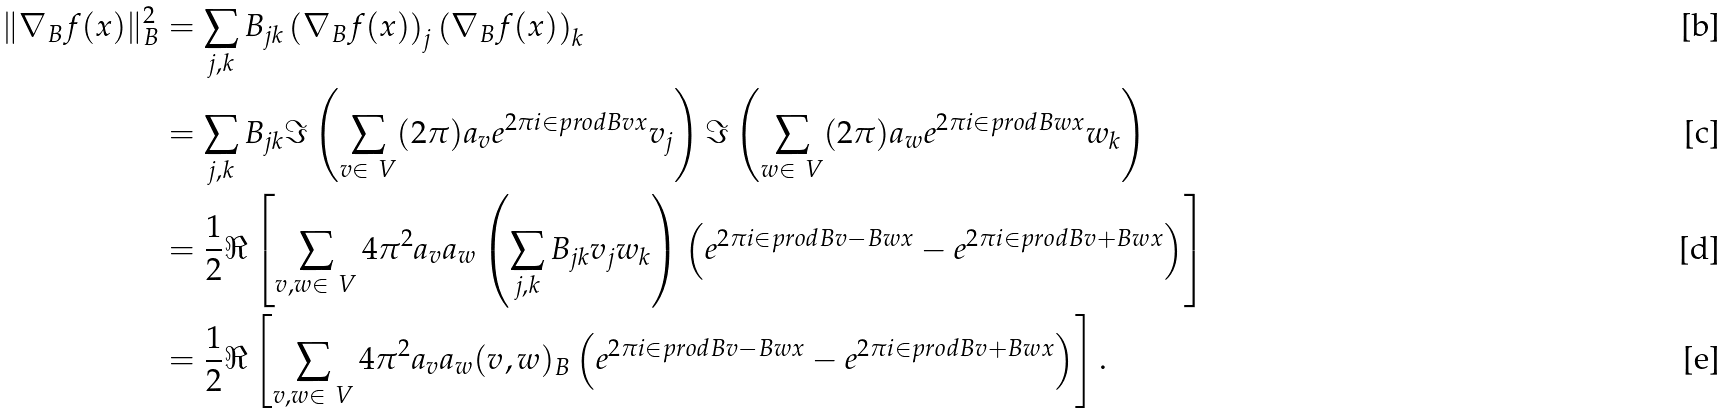<formula> <loc_0><loc_0><loc_500><loc_500>\| \nabla _ { B } f ( x ) \| _ { B } ^ { 2 } & = \sum _ { j , k } B _ { j k } \left ( \nabla _ { B } f ( x ) \right ) _ { j } \left ( \nabla _ { B } f ( x ) \right ) _ { k } \\ & = \sum _ { j , k } B _ { j k } \Im \left ( \sum _ { v \in \ V } ( 2 \pi ) a _ { v } e ^ { 2 \pi i \in p r o d { B v } { x } } v _ { j } \right ) \Im \left ( \sum _ { w \in \ V } ( 2 \pi ) a _ { w } e ^ { 2 \pi i \in p r o d { B w } { x } } w _ { k } \right ) \\ & = \frac { 1 } { 2 } \Re \left [ \sum _ { v , w \in \ V } 4 \pi ^ { 2 } a _ { v } a _ { w } \left ( \sum _ { j , k } B _ { j k } v _ { j } w _ { k } \right ) \left ( e ^ { 2 \pi i \in p r o d { B v - B w } { x } } - e ^ { 2 \pi i \in p r o d { B v + B w } { x } } \right ) \right ] \\ & = \frac { 1 } { 2 } \Re \left [ \sum _ { v , w \in \ V } 4 \pi ^ { 2 } a _ { v } a _ { w } ( v , w ) _ { B } \left ( e ^ { 2 \pi i \in p r o d { B v - B w } { x } } - e ^ { 2 \pi i \in p r o d { B v + B w } { x } } \right ) \right ] .</formula> 